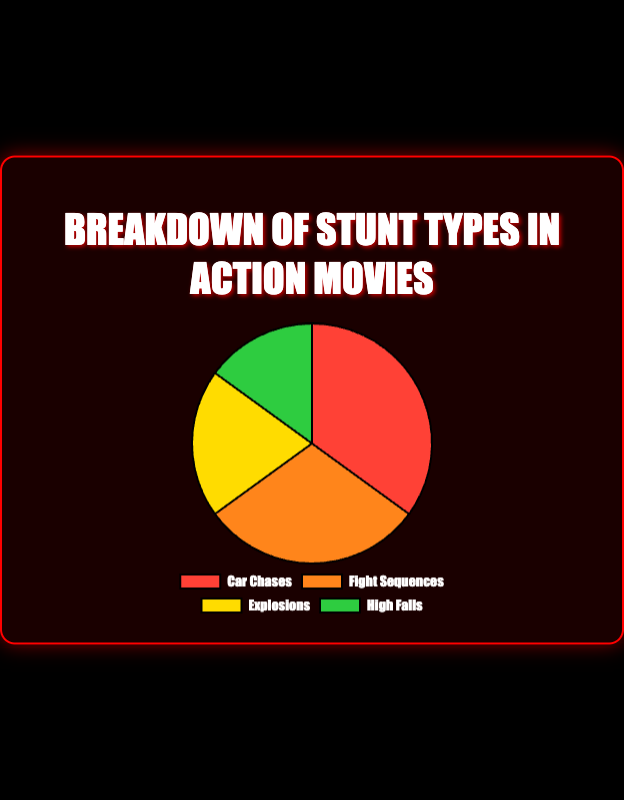Which stunt type has the highest percentage? The pie chart shows four stunt types with their respective percentages. Among these, "Car Chases" has the highest percentage at 35%.
Answer: Car Chases Which stunt type appears in action movies the least? The pie chart labels indicate the percentage of each stunt type used in action movies. "High Falls" has the lowest percentage at 15%.
Answer: High Falls What is the combined percentage of explosions and high falls? To find the total percentage for "Explosions" and "High Falls," we sum their respective percentages: 20% (Explosions) + 15% (High Falls) = 35%.
Answer: 35% Are car chases more common than fight sequences in action movies? According to the pie chart, "Car Chases" have a percentage of 35%, while "Fight Sequences" have a percentage of 30%. Since 35% is greater than 30%, car chases are more common.
Answer: Yes What is the difference in percentage between the most and least common stunt types? The most common stunt type is "Car Chases" at 35%, and the least common stunt type is "High Falls" at 15%. The difference is 35% - 15% = 20%.
Answer: 20% What color represents the fight sequences in the pie chart? The pie chart uses different colors to represent each stunt type. "Fight Sequences" are depicted in the orange section of the pie chart.
Answer: Orange What two stunt types together make up more than half of the stunt types used? To find two stunt types that make up more than 50%, we look for the two largest segments. "Car Chases" (35%) and "Fight Sequences" (30%) together make 35% + 30% = 65%, which is more than half.
Answer: Car Chases & Fight Sequences Are explosions and high falls used equally in action movies? The pie chart shows that "Explosions" account for 20% and "High Falls" for 15%. Since 20% is not equal to 15%, they are not used equally.
Answer: No What percentage of the stunts consist of either car chases or explosions? To find the total percentage, sum the percentages of "Car Chases" (35%) and "Explosions" (20%): 35% + 20% = 55%.
Answer: 55% Is the sum of the percentages for fight sequences and high falls less than or greater than car chases? The percentages for "Fight Sequences" is 30% and for "High Falls" is 15%. Their sum is 30% + 15% = 45%. Comparing this to "Car Chases" at 35%, 45% is greater than 35%.
Answer: Greater than 